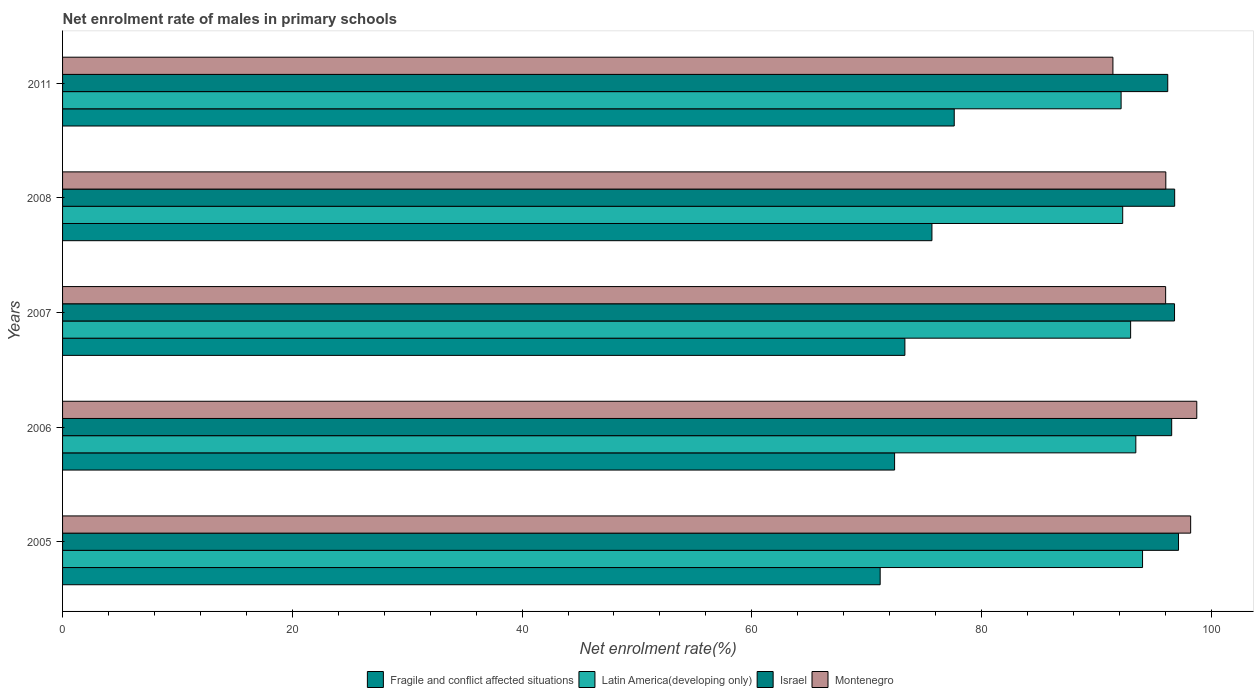How many different coloured bars are there?
Offer a very short reply. 4. How many bars are there on the 1st tick from the top?
Provide a succinct answer. 4. In how many cases, is the number of bars for a given year not equal to the number of legend labels?
Your answer should be very brief. 0. What is the net enrolment rate of males in primary schools in Montenegro in 2006?
Offer a terse response. 98.73. Across all years, what is the maximum net enrolment rate of males in primary schools in Israel?
Offer a very short reply. 97.15. Across all years, what is the minimum net enrolment rate of males in primary schools in Fragile and conflict affected situations?
Your response must be concise. 71.17. In which year was the net enrolment rate of males in primary schools in Montenegro maximum?
Offer a terse response. 2006. What is the total net enrolment rate of males in primary schools in Israel in the graph?
Provide a succinct answer. 483.51. What is the difference between the net enrolment rate of males in primary schools in Israel in 2008 and that in 2011?
Your answer should be very brief. 0.6. What is the difference between the net enrolment rate of males in primary schools in Fragile and conflict affected situations in 2005 and the net enrolment rate of males in primary schools in Latin America(developing only) in 2011?
Offer a very short reply. -20.97. What is the average net enrolment rate of males in primary schools in Montenegro per year?
Your answer should be very brief. 96.09. In the year 2008, what is the difference between the net enrolment rate of males in primary schools in Fragile and conflict affected situations and net enrolment rate of males in primary schools in Israel?
Your answer should be compact. -21.13. What is the ratio of the net enrolment rate of males in primary schools in Montenegro in 2007 to that in 2008?
Give a very brief answer. 1. Is the difference between the net enrolment rate of males in primary schools in Fragile and conflict affected situations in 2005 and 2007 greater than the difference between the net enrolment rate of males in primary schools in Israel in 2005 and 2007?
Give a very brief answer. No. What is the difference between the highest and the second highest net enrolment rate of males in primary schools in Israel?
Keep it short and to the point. 0.33. What is the difference between the highest and the lowest net enrolment rate of males in primary schools in Fragile and conflict affected situations?
Offer a very short reply. 6.45. What does the 3rd bar from the top in 2008 represents?
Provide a short and direct response. Latin America(developing only). What does the 3rd bar from the bottom in 2007 represents?
Your answer should be very brief. Israel. Are all the bars in the graph horizontal?
Offer a terse response. Yes. How many years are there in the graph?
Keep it short and to the point. 5. Does the graph contain any zero values?
Your response must be concise. No. Where does the legend appear in the graph?
Your answer should be compact. Bottom center. What is the title of the graph?
Ensure brevity in your answer.  Net enrolment rate of males in primary schools. Does "Channel Islands" appear as one of the legend labels in the graph?
Give a very brief answer. No. What is the label or title of the X-axis?
Provide a succinct answer. Net enrolment rate(%). What is the Net enrolment rate(%) in Fragile and conflict affected situations in 2005?
Your response must be concise. 71.17. What is the Net enrolment rate(%) in Latin America(developing only) in 2005?
Your answer should be compact. 94.01. What is the Net enrolment rate(%) of Israel in 2005?
Ensure brevity in your answer.  97.15. What is the Net enrolment rate(%) of Montenegro in 2005?
Keep it short and to the point. 98.2. What is the Net enrolment rate(%) of Fragile and conflict affected situations in 2006?
Offer a very short reply. 72.43. What is the Net enrolment rate(%) of Latin America(developing only) in 2006?
Provide a short and direct response. 93.43. What is the Net enrolment rate(%) in Israel in 2006?
Offer a very short reply. 96.55. What is the Net enrolment rate(%) of Montenegro in 2006?
Keep it short and to the point. 98.73. What is the Net enrolment rate(%) of Fragile and conflict affected situations in 2007?
Your answer should be very brief. 73.33. What is the Net enrolment rate(%) in Latin America(developing only) in 2007?
Offer a terse response. 92.98. What is the Net enrolment rate(%) of Israel in 2007?
Keep it short and to the point. 96.8. What is the Net enrolment rate(%) in Montenegro in 2007?
Offer a very short reply. 96.02. What is the Net enrolment rate(%) of Fragile and conflict affected situations in 2008?
Give a very brief answer. 75.68. What is the Net enrolment rate(%) in Latin America(developing only) in 2008?
Provide a succinct answer. 92.29. What is the Net enrolment rate(%) in Israel in 2008?
Keep it short and to the point. 96.81. What is the Net enrolment rate(%) in Montenegro in 2008?
Make the answer very short. 96.04. What is the Net enrolment rate(%) of Fragile and conflict affected situations in 2011?
Offer a terse response. 77.62. What is the Net enrolment rate(%) of Latin America(developing only) in 2011?
Your answer should be very brief. 92.15. What is the Net enrolment rate(%) of Israel in 2011?
Make the answer very short. 96.21. What is the Net enrolment rate(%) in Montenegro in 2011?
Your answer should be very brief. 91.44. Across all years, what is the maximum Net enrolment rate(%) in Fragile and conflict affected situations?
Offer a very short reply. 77.62. Across all years, what is the maximum Net enrolment rate(%) in Latin America(developing only)?
Your answer should be compact. 94.01. Across all years, what is the maximum Net enrolment rate(%) in Israel?
Provide a short and direct response. 97.15. Across all years, what is the maximum Net enrolment rate(%) in Montenegro?
Your response must be concise. 98.73. Across all years, what is the minimum Net enrolment rate(%) in Fragile and conflict affected situations?
Provide a short and direct response. 71.17. Across all years, what is the minimum Net enrolment rate(%) in Latin America(developing only)?
Your response must be concise. 92.15. Across all years, what is the minimum Net enrolment rate(%) in Israel?
Ensure brevity in your answer.  96.21. Across all years, what is the minimum Net enrolment rate(%) of Montenegro?
Provide a succinct answer. 91.44. What is the total Net enrolment rate(%) of Fragile and conflict affected situations in the graph?
Keep it short and to the point. 370.23. What is the total Net enrolment rate(%) in Latin America(developing only) in the graph?
Provide a short and direct response. 464.85. What is the total Net enrolment rate(%) in Israel in the graph?
Give a very brief answer. 483.51. What is the total Net enrolment rate(%) in Montenegro in the graph?
Your answer should be compact. 480.44. What is the difference between the Net enrolment rate(%) in Fragile and conflict affected situations in 2005 and that in 2006?
Offer a very short reply. -1.26. What is the difference between the Net enrolment rate(%) in Latin America(developing only) in 2005 and that in 2006?
Give a very brief answer. 0.58. What is the difference between the Net enrolment rate(%) in Israel in 2005 and that in 2006?
Offer a terse response. 0.6. What is the difference between the Net enrolment rate(%) of Montenegro in 2005 and that in 2006?
Make the answer very short. -0.53. What is the difference between the Net enrolment rate(%) in Fragile and conflict affected situations in 2005 and that in 2007?
Your answer should be compact. -2.15. What is the difference between the Net enrolment rate(%) of Latin America(developing only) in 2005 and that in 2007?
Offer a terse response. 1.04. What is the difference between the Net enrolment rate(%) in Israel in 2005 and that in 2007?
Provide a succinct answer. 0.35. What is the difference between the Net enrolment rate(%) of Montenegro in 2005 and that in 2007?
Keep it short and to the point. 2.18. What is the difference between the Net enrolment rate(%) of Fragile and conflict affected situations in 2005 and that in 2008?
Offer a very short reply. -4.51. What is the difference between the Net enrolment rate(%) in Latin America(developing only) in 2005 and that in 2008?
Offer a very short reply. 1.73. What is the difference between the Net enrolment rate(%) in Israel in 2005 and that in 2008?
Offer a terse response. 0.33. What is the difference between the Net enrolment rate(%) of Montenegro in 2005 and that in 2008?
Your answer should be compact. 2.16. What is the difference between the Net enrolment rate(%) in Fragile and conflict affected situations in 2005 and that in 2011?
Ensure brevity in your answer.  -6.45. What is the difference between the Net enrolment rate(%) of Latin America(developing only) in 2005 and that in 2011?
Make the answer very short. 1.87. What is the difference between the Net enrolment rate(%) of Israel in 2005 and that in 2011?
Make the answer very short. 0.94. What is the difference between the Net enrolment rate(%) of Montenegro in 2005 and that in 2011?
Keep it short and to the point. 6.77. What is the difference between the Net enrolment rate(%) in Fragile and conflict affected situations in 2006 and that in 2007?
Ensure brevity in your answer.  -0.9. What is the difference between the Net enrolment rate(%) of Latin America(developing only) in 2006 and that in 2007?
Your answer should be very brief. 0.45. What is the difference between the Net enrolment rate(%) of Israel in 2006 and that in 2007?
Your answer should be very brief. -0.25. What is the difference between the Net enrolment rate(%) of Montenegro in 2006 and that in 2007?
Your answer should be very brief. 2.71. What is the difference between the Net enrolment rate(%) in Fragile and conflict affected situations in 2006 and that in 2008?
Give a very brief answer. -3.25. What is the difference between the Net enrolment rate(%) of Latin America(developing only) in 2006 and that in 2008?
Offer a terse response. 1.14. What is the difference between the Net enrolment rate(%) of Israel in 2006 and that in 2008?
Give a very brief answer. -0.26. What is the difference between the Net enrolment rate(%) in Montenegro in 2006 and that in 2008?
Your answer should be compact. 2.7. What is the difference between the Net enrolment rate(%) of Fragile and conflict affected situations in 2006 and that in 2011?
Provide a short and direct response. -5.19. What is the difference between the Net enrolment rate(%) of Latin America(developing only) in 2006 and that in 2011?
Keep it short and to the point. 1.28. What is the difference between the Net enrolment rate(%) in Israel in 2006 and that in 2011?
Provide a short and direct response. 0.34. What is the difference between the Net enrolment rate(%) in Montenegro in 2006 and that in 2011?
Your answer should be compact. 7.3. What is the difference between the Net enrolment rate(%) in Fragile and conflict affected situations in 2007 and that in 2008?
Keep it short and to the point. -2.35. What is the difference between the Net enrolment rate(%) of Latin America(developing only) in 2007 and that in 2008?
Your response must be concise. 0.69. What is the difference between the Net enrolment rate(%) of Israel in 2007 and that in 2008?
Make the answer very short. -0.01. What is the difference between the Net enrolment rate(%) in Montenegro in 2007 and that in 2008?
Provide a succinct answer. -0.02. What is the difference between the Net enrolment rate(%) in Fragile and conflict affected situations in 2007 and that in 2011?
Ensure brevity in your answer.  -4.3. What is the difference between the Net enrolment rate(%) in Latin America(developing only) in 2007 and that in 2011?
Provide a succinct answer. 0.83. What is the difference between the Net enrolment rate(%) of Israel in 2007 and that in 2011?
Give a very brief answer. 0.59. What is the difference between the Net enrolment rate(%) in Montenegro in 2007 and that in 2011?
Ensure brevity in your answer.  4.59. What is the difference between the Net enrolment rate(%) in Fragile and conflict affected situations in 2008 and that in 2011?
Provide a succinct answer. -1.94. What is the difference between the Net enrolment rate(%) in Latin America(developing only) in 2008 and that in 2011?
Keep it short and to the point. 0.14. What is the difference between the Net enrolment rate(%) of Israel in 2008 and that in 2011?
Give a very brief answer. 0.6. What is the difference between the Net enrolment rate(%) in Montenegro in 2008 and that in 2011?
Give a very brief answer. 4.6. What is the difference between the Net enrolment rate(%) in Fragile and conflict affected situations in 2005 and the Net enrolment rate(%) in Latin America(developing only) in 2006?
Offer a very short reply. -22.25. What is the difference between the Net enrolment rate(%) in Fragile and conflict affected situations in 2005 and the Net enrolment rate(%) in Israel in 2006?
Offer a terse response. -25.38. What is the difference between the Net enrolment rate(%) of Fragile and conflict affected situations in 2005 and the Net enrolment rate(%) of Montenegro in 2006?
Offer a very short reply. -27.56. What is the difference between the Net enrolment rate(%) in Latin America(developing only) in 2005 and the Net enrolment rate(%) in Israel in 2006?
Make the answer very short. -2.54. What is the difference between the Net enrolment rate(%) of Latin America(developing only) in 2005 and the Net enrolment rate(%) of Montenegro in 2006?
Keep it short and to the point. -4.72. What is the difference between the Net enrolment rate(%) of Israel in 2005 and the Net enrolment rate(%) of Montenegro in 2006?
Make the answer very short. -1.59. What is the difference between the Net enrolment rate(%) in Fragile and conflict affected situations in 2005 and the Net enrolment rate(%) in Latin America(developing only) in 2007?
Your answer should be very brief. -21.8. What is the difference between the Net enrolment rate(%) of Fragile and conflict affected situations in 2005 and the Net enrolment rate(%) of Israel in 2007?
Keep it short and to the point. -25.62. What is the difference between the Net enrolment rate(%) in Fragile and conflict affected situations in 2005 and the Net enrolment rate(%) in Montenegro in 2007?
Offer a terse response. -24.85. What is the difference between the Net enrolment rate(%) of Latin America(developing only) in 2005 and the Net enrolment rate(%) of Israel in 2007?
Make the answer very short. -2.78. What is the difference between the Net enrolment rate(%) in Latin America(developing only) in 2005 and the Net enrolment rate(%) in Montenegro in 2007?
Provide a short and direct response. -2.01. What is the difference between the Net enrolment rate(%) of Israel in 2005 and the Net enrolment rate(%) of Montenegro in 2007?
Keep it short and to the point. 1.12. What is the difference between the Net enrolment rate(%) of Fragile and conflict affected situations in 2005 and the Net enrolment rate(%) of Latin America(developing only) in 2008?
Offer a terse response. -21.11. What is the difference between the Net enrolment rate(%) of Fragile and conflict affected situations in 2005 and the Net enrolment rate(%) of Israel in 2008?
Your response must be concise. -25.64. What is the difference between the Net enrolment rate(%) in Fragile and conflict affected situations in 2005 and the Net enrolment rate(%) in Montenegro in 2008?
Make the answer very short. -24.87. What is the difference between the Net enrolment rate(%) of Latin America(developing only) in 2005 and the Net enrolment rate(%) of Israel in 2008?
Provide a short and direct response. -2.8. What is the difference between the Net enrolment rate(%) of Latin America(developing only) in 2005 and the Net enrolment rate(%) of Montenegro in 2008?
Your answer should be compact. -2.03. What is the difference between the Net enrolment rate(%) in Israel in 2005 and the Net enrolment rate(%) in Montenegro in 2008?
Give a very brief answer. 1.11. What is the difference between the Net enrolment rate(%) in Fragile and conflict affected situations in 2005 and the Net enrolment rate(%) in Latin America(developing only) in 2011?
Give a very brief answer. -20.97. What is the difference between the Net enrolment rate(%) in Fragile and conflict affected situations in 2005 and the Net enrolment rate(%) in Israel in 2011?
Your answer should be very brief. -25.03. What is the difference between the Net enrolment rate(%) of Fragile and conflict affected situations in 2005 and the Net enrolment rate(%) of Montenegro in 2011?
Your answer should be very brief. -20.26. What is the difference between the Net enrolment rate(%) in Latin America(developing only) in 2005 and the Net enrolment rate(%) in Israel in 2011?
Give a very brief answer. -2.19. What is the difference between the Net enrolment rate(%) in Latin America(developing only) in 2005 and the Net enrolment rate(%) in Montenegro in 2011?
Provide a succinct answer. 2.58. What is the difference between the Net enrolment rate(%) of Israel in 2005 and the Net enrolment rate(%) of Montenegro in 2011?
Your response must be concise. 5.71. What is the difference between the Net enrolment rate(%) in Fragile and conflict affected situations in 2006 and the Net enrolment rate(%) in Latin America(developing only) in 2007?
Offer a terse response. -20.55. What is the difference between the Net enrolment rate(%) of Fragile and conflict affected situations in 2006 and the Net enrolment rate(%) of Israel in 2007?
Give a very brief answer. -24.37. What is the difference between the Net enrolment rate(%) of Fragile and conflict affected situations in 2006 and the Net enrolment rate(%) of Montenegro in 2007?
Ensure brevity in your answer.  -23.6. What is the difference between the Net enrolment rate(%) in Latin America(developing only) in 2006 and the Net enrolment rate(%) in Israel in 2007?
Your response must be concise. -3.37. What is the difference between the Net enrolment rate(%) in Latin America(developing only) in 2006 and the Net enrolment rate(%) in Montenegro in 2007?
Provide a succinct answer. -2.6. What is the difference between the Net enrolment rate(%) in Israel in 2006 and the Net enrolment rate(%) in Montenegro in 2007?
Your response must be concise. 0.53. What is the difference between the Net enrolment rate(%) of Fragile and conflict affected situations in 2006 and the Net enrolment rate(%) of Latin America(developing only) in 2008?
Your answer should be very brief. -19.86. What is the difference between the Net enrolment rate(%) of Fragile and conflict affected situations in 2006 and the Net enrolment rate(%) of Israel in 2008?
Your response must be concise. -24.38. What is the difference between the Net enrolment rate(%) in Fragile and conflict affected situations in 2006 and the Net enrolment rate(%) in Montenegro in 2008?
Your answer should be very brief. -23.61. What is the difference between the Net enrolment rate(%) of Latin America(developing only) in 2006 and the Net enrolment rate(%) of Israel in 2008?
Your answer should be very brief. -3.38. What is the difference between the Net enrolment rate(%) of Latin America(developing only) in 2006 and the Net enrolment rate(%) of Montenegro in 2008?
Provide a succinct answer. -2.61. What is the difference between the Net enrolment rate(%) in Israel in 2006 and the Net enrolment rate(%) in Montenegro in 2008?
Offer a very short reply. 0.51. What is the difference between the Net enrolment rate(%) in Fragile and conflict affected situations in 2006 and the Net enrolment rate(%) in Latin America(developing only) in 2011?
Provide a short and direct response. -19.72. What is the difference between the Net enrolment rate(%) in Fragile and conflict affected situations in 2006 and the Net enrolment rate(%) in Israel in 2011?
Give a very brief answer. -23.78. What is the difference between the Net enrolment rate(%) of Fragile and conflict affected situations in 2006 and the Net enrolment rate(%) of Montenegro in 2011?
Keep it short and to the point. -19.01. What is the difference between the Net enrolment rate(%) of Latin America(developing only) in 2006 and the Net enrolment rate(%) of Israel in 2011?
Your answer should be very brief. -2.78. What is the difference between the Net enrolment rate(%) in Latin America(developing only) in 2006 and the Net enrolment rate(%) in Montenegro in 2011?
Your response must be concise. 1.99. What is the difference between the Net enrolment rate(%) in Israel in 2006 and the Net enrolment rate(%) in Montenegro in 2011?
Your answer should be compact. 5.12. What is the difference between the Net enrolment rate(%) of Fragile and conflict affected situations in 2007 and the Net enrolment rate(%) of Latin America(developing only) in 2008?
Offer a very short reply. -18.96. What is the difference between the Net enrolment rate(%) of Fragile and conflict affected situations in 2007 and the Net enrolment rate(%) of Israel in 2008?
Your answer should be very brief. -23.48. What is the difference between the Net enrolment rate(%) in Fragile and conflict affected situations in 2007 and the Net enrolment rate(%) in Montenegro in 2008?
Provide a short and direct response. -22.71. What is the difference between the Net enrolment rate(%) of Latin America(developing only) in 2007 and the Net enrolment rate(%) of Israel in 2008?
Keep it short and to the point. -3.83. What is the difference between the Net enrolment rate(%) of Latin America(developing only) in 2007 and the Net enrolment rate(%) of Montenegro in 2008?
Provide a short and direct response. -3.06. What is the difference between the Net enrolment rate(%) in Israel in 2007 and the Net enrolment rate(%) in Montenegro in 2008?
Offer a terse response. 0.76. What is the difference between the Net enrolment rate(%) in Fragile and conflict affected situations in 2007 and the Net enrolment rate(%) in Latin America(developing only) in 2011?
Your response must be concise. -18.82. What is the difference between the Net enrolment rate(%) of Fragile and conflict affected situations in 2007 and the Net enrolment rate(%) of Israel in 2011?
Ensure brevity in your answer.  -22.88. What is the difference between the Net enrolment rate(%) of Fragile and conflict affected situations in 2007 and the Net enrolment rate(%) of Montenegro in 2011?
Your answer should be very brief. -18.11. What is the difference between the Net enrolment rate(%) in Latin America(developing only) in 2007 and the Net enrolment rate(%) in Israel in 2011?
Keep it short and to the point. -3.23. What is the difference between the Net enrolment rate(%) of Latin America(developing only) in 2007 and the Net enrolment rate(%) of Montenegro in 2011?
Provide a succinct answer. 1.54. What is the difference between the Net enrolment rate(%) in Israel in 2007 and the Net enrolment rate(%) in Montenegro in 2011?
Give a very brief answer. 5.36. What is the difference between the Net enrolment rate(%) in Fragile and conflict affected situations in 2008 and the Net enrolment rate(%) in Latin America(developing only) in 2011?
Your answer should be compact. -16.47. What is the difference between the Net enrolment rate(%) of Fragile and conflict affected situations in 2008 and the Net enrolment rate(%) of Israel in 2011?
Make the answer very short. -20.53. What is the difference between the Net enrolment rate(%) in Fragile and conflict affected situations in 2008 and the Net enrolment rate(%) in Montenegro in 2011?
Offer a terse response. -15.76. What is the difference between the Net enrolment rate(%) of Latin America(developing only) in 2008 and the Net enrolment rate(%) of Israel in 2011?
Your response must be concise. -3.92. What is the difference between the Net enrolment rate(%) of Latin America(developing only) in 2008 and the Net enrolment rate(%) of Montenegro in 2011?
Ensure brevity in your answer.  0.85. What is the difference between the Net enrolment rate(%) in Israel in 2008 and the Net enrolment rate(%) in Montenegro in 2011?
Your answer should be very brief. 5.38. What is the average Net enrolment rate(%) in Fragile and conflict affected situations per year?
Give a very brief answer. 74.05. What is the average Net enrolment rate(%) in Latin America(developing only) per year?
Your response must be concise. 92.97. What is the average Net enrolment rate(%) in Israel per year?
Provide a succinct answer. 96.7. What is the average Net enrolment rate(%) of Montenegro per year?
Your response must be concise. 96.09. In the year 2005, what is the difference between the Net enrolment rate(%) of Fragile and conflict affected situations and Net enrolment rate(%) of Latin America(developing only)?
Provide a short and direct response. -22.84. In the year 2005, what is the difference between the Net enrolment rate(%) of Fragile and conflict affected situations and Net enrolment rate(%) of Israel?
Your response must be concise. -25.97. In the year 2005, what is the difference between the Net enrolment rate(%) in Fragile and conflict affected situations and Net enrolment rate(%) in Montenegro?
Provide a short and direct response. -27.03. In the year 2005, what is the difference between the Net enrolment rate(%) of Latin America(developing only) and Net enrolment rate(%) of Israel?
Ensure brevity in your answer.  -3.13. In the year 2005, what is the difference between the Net enrolment rate(%) of Latin America(developing only) and Net enrolment rate(%) of Montenegro?
Your response must be concise. -4.19. In the year 2005, what is the difference between the Net enrolment rate(%) in Israel and Net enrolment rate(%) in Montenegro?
Give a very brief answer. -1.06. In the year 2006, what is the difference between the Net enrolment rate(%) of Fragile and conflict affected situations and Net enrolment rate(%) of Latin America(developing only)?
Your answer should be very brief. -21. In the year 2006, what is the difference between the Net enrolment rate(%) of Fragile and conflict affected situations and Net enrolment rate(%) of Israel?
Give a very brief answer. -24.12. In the year 2006, what is the difference between the Net enrolment rate(%) of Fragile and conflict affected situations and Net enrolment rate(%) of Montenegro?
Provide a short and direct response. -26.31. In the year 2006, what is the difference between the Net enrolment rate(%) of Latin America(developing only) and Net enrolment rate(%) of Israel?
Give a very brief answer. -3.12. In the year 2006, what is the difference between the Net enrolment rate(%) in Latin America(developing only) and Net enrolment rate(%) in Montenegro?
Your response must be concise. -5.31. In the year 2006, what is the difference between the Net enrolment rate(%) of Israel and Net enrolment rate(%) of Montenegro?
Provide a short and direct response. -2.18. In the year 2007, what is the difference between the Net enrolment rate(%) in Fragile and conflict affected situations and Net enrolment rate(%) in Latin America(developing only)?
Ensure brevity in your answer.  -19.65. In the year 2007, what is the difference between the Net enrolment rate(%) in Fragile and conflict affected situations and Net enrolment rate(%) in Israel?
Make the answer very short. -23.47. In the year 2007, what is the difference between the Net enrolment rate(%) of Fragile and conflict affected situations and Net enrolment rate(%) of Montenegro?
Your answer should be compact. -22.7. In the year 2007, what is the difference between the Net enrolment rate(%) in Latin America(developing only) and Net enrolment rate(%) in Israel?
Your response must be concise. -3.82. In the year 2007, what is the difference between the Net enrolment rate(%) in Latin America(developing only) and Net enrolment rate(%) in Montenegro?
Offer a very short reply. -3.05. In the year 2007, what is the difference between the Net enrolment rate(%) in Israel and Net enrolment rate(%) in Montenegro?
Your answer should be compact. 0.77. In the year 2008, what is the difference between the Net enrolment rate(%) in Fragile and conflict affected situations and Net enrolment rate(%) in Latin America(developing only)?
Your answer should be very brief. -16.61. In the year 2008, what is the difference between the Net enrolment rate(%) in Fragile and conflict affected situations and Net enrolment rate(%) in Israel?
Keep it short and to the point. -21.13. In the year 2008, what is the difference between the Net enrolment rate(%) in Fragile and conflict affected situations and Net enrolment rate(%) in Montenegro?
Your answer should be very brief. -20.36. In the year 2008, what is the difference between the Net enrolment rate(%) in Latin America(developing only) and Net enrolment rate(%) in Israel?
Offer a very short reply. -4.52. In the year 2008, what is the difference between the Net enrolment rate(%) of Latin America(developing only) and Net enrolment rate(%) of Montenegro?
Keep it short and to the point. -3.75. In the year 2008, what is the difference between the Net enrolment rate(%) in Israel and Net enrolment rate(%) in Montenegro?
Make the answer very short. 0.77. In the year 2011, what is the difference between the Net enrolment rate(%) of Fragile and conflict affected situations and Net enrolment rate(%) of Latin America(developing only)?
Your answer should be compact. -14.53. In the year 2011, what is the difference between the Net enrolment rate(%) of Fragile and conflict affected situations and Net enrolment rate(%) of Israel?
Ensure brevity in your answer.  -18.59. In the year 2011, what is the difference between the Net enrolment rate(%) in Fragile and conflict affected situations and Net enrolment rate(%) in Montenegro?
Provide a short and direct response. -13.81. In the year 2011, what is the difference between the Net enrolment rate(%) of Latin America(developing only) and Net enrolment rate(%) of Israel?
Your answer should be very brief. -4.06. In the year 2011, what is the difference between the Net enrolment rate(%) of Latin America(developing only) and Net enrolment rate(%) of Montenegro?
Your answer should be very brief. 0.71. In the year 2011, what is the difference between the Net enrolment rate(%) in Israel and Net enrolment rate(%) in Montenegro?
Your answer should be compact. 4.77. What is the ratio of the Net enrolment rate(%) of Fragile and conflict affected situations in 2005 to that in 2006?
Give a very brief answer. 0.98. What is the ratio of the Net enrolment rate(%) of Israel in 2005 to that in 2006?
Provide a succinct answer. 1.01. What is the ratio of the Net enrolment rate(%) of Montenegro in 2005 to that in 2006?
Offer a very short reply. 0.99. What is the ratio of the Net enrolment rate(%) of Fragile and conflict affected situations in 2005 to that in 2007?
Keep it short and to the point. 0.97. What is the ratio of the Net enrolment rate(%) of Latin America(developing only) in 2005 to that in 2007?
Give a very brief answer. 1.01. What is the ratio of the Net enrolment rate(%) of Israel in 2005 to that in 2007?
Your answer should be compact. 1. What is the ratio of the Net enrolment rate(%) of Montenegro in 2005 to that in 2007?
Your answer should be very brief. 1.02. What is the ratio of the Net enrolment rate(%) of Fragile and conflict affected situations in 2005 to that in 2008?
Give a very brief answer. 0.94. What is the ratio of the Net enrolment rate(%) of Latin America(developing only) in 2005 to that in 2008?
Provide a succinct answer. 1.02. What is the ratio of the Net enrolment rate(%) in Israel in 2005 to that in 2008?
Provide a short and direct response. 1. What is the ratio of the Net enrolment rate(%) in Montenegro in 2005 to that in 2008?
Your answer should be very brief. 1.02. What is the ratio of the Net enrolment rate(%) of Fragile and conflict affected situations in 2005 to that in 2011?
Provide a short and direct response. 0.92. What is the ratio of the Net enrolment rate(%) in Latin America(developing only) in 2005 to that in 2011?
Your answer should be compact. 1.02. What is the ratio of the Net enrolment rate(%) in Israel in 2005 to that in 2011?
Offer a terse response. 1.01. What is the ratio of the Net enrolment rate(%) of Montenegro in 2005 to that in 2011?
Give a very brief answer. 1.07. What is the ratio of the Net enrolment rate(%) of Fragile and conflict affected situations in 2006 to that in 2007?
Offer a very short reply. 0.99. What is the ratio of the Net enrolment rate(%) of Latin America(developing only) in 2006 to that in 2007?
Provide a succinct answer. 1. What is the ratio of the Net enrolment rate(%) in Israel in 2006 to that in 2007?
Make the answer very short. 1. What is the ratio of the Net enrolment rate(%) of Montenegro in 2006 to that in 2007?
Offer a very short reply. 1.03. What is the ratio of the Net enrolment rate(%) in Fragile and conflict affected situations in 2006 to that in 2008?
Offer a terse response. 0.96. What is the ratio of the Net enrolment rate(%) in Latin America(developing only) in 2006 to that in 2008?
Your answer should be compact. 1.01. What is the ratio of the Net enrolment rate(%) of Montenegro in 2006 to that in 2008?
Offer a terse response. 1.03. What is the ratio of the Net enrolment rate(%) of Fragile and conflict affected situations in 2006 to that in 2011?
Provide a succinct answer. 0.93. What is the ratio of the Net enrolment rate(%) in Latin America(developing only) in 2006 to that in 2011?
Provide a succinct answer. 1.01. What is the ratio of the Net enrolment rate(%) in Montenegro in 2006 to that in 2011?
Keep it short and to the point. 1.08. What is the ratio of the Net enrolment rate(%) in Fragile and conflict affected situations in 2007 to that in 2008?
Provide a succinct answer. 0.97. What is the ratio of the Net enrolment rate(%) in Latin America(developing only) in 2007 to that in 2008?
Ensure brevity in your answer.  1.01. What is the ratio of the Net enrolment rate(%) in Israel in 2007 to that in 2008?
Your response must be concise. 1. What is the ratio of the Net enrolment rate(%) in Fragile and conflict affected situations in 2007 to that in 2011?
Keep it short and to the point. 0.94. What is the ratio of the Net enrolment rate(%) in Latin America(developing only) in 2007 to that in 2011?
Offer a very short reply. 1.01. What is the ratio of the Net enrolment rate(%) of Montenegro in 2007 to that in 2011?
Provide a succinct answer. 1.05. What is the ratio of the Net enrolment rate(%) in Fragile and conflict affected situations in 2008 to that in 2011?
Offer a terse response. 0.97. What is the ratio of the Net enrolment rate(%) of Israel in 2008 to that in 2011?
Make the answer very short. 1.01. What is the ratio of the Net enrolment rate(%) in Montenegro in 2008 to that in 2011?
Your answer should be compact. 1.05. What is the difference between the highest and the second highest Net enrolment rate(%) in Fragile and conflict affected situations?
Make the answer very short. 1.94. What is the difference between the highest and the second highest Net enrolment rate(%) in Latin America(developing only)?
Provide a short and direct response. 0.58. What is the difference between the highest and the second highest Net enrolment rate(%) of Israel?
Your answer should be very brief. 0.33. What is the difference between the highest and the second highest Net enrolment rate(%) of Montenegro?
Your response must be concise. 0.53. What is the difference between the highest and the lowest Net enrolment rate(%) of Fragile and conflict affected situations?
Ensure brevity in your answer.  6.45. What is the difference between the highest and the lowest Net enrolment rate(%) of Latin America(developing only)?
Offer a very short reply. 1.87. What is the difference between the highest and the lowest Net enrolment rate(%) in Israel?
Provide a succinct answer. 0.94. What is the difference between the highest and the lowest Net enrolment rate(%) in Montenegro?
Make the answer very short. 7.3. 